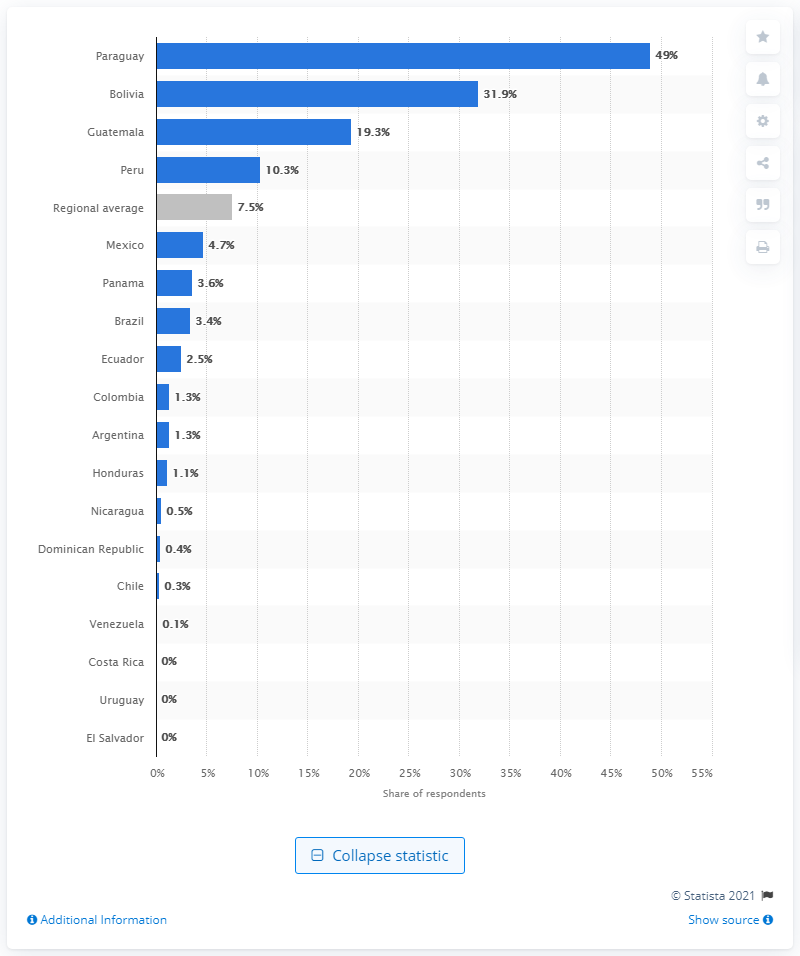Outline some significant characteristics in this image. The Latin American survey revealed that Bolivia came in second. A significant percentage of Latin Americans speak a native or indigenous language as their mother tongue, with 7.5% of the population speaking these languages. In Paraguay, a significant percentage of the population speaks their first language. 